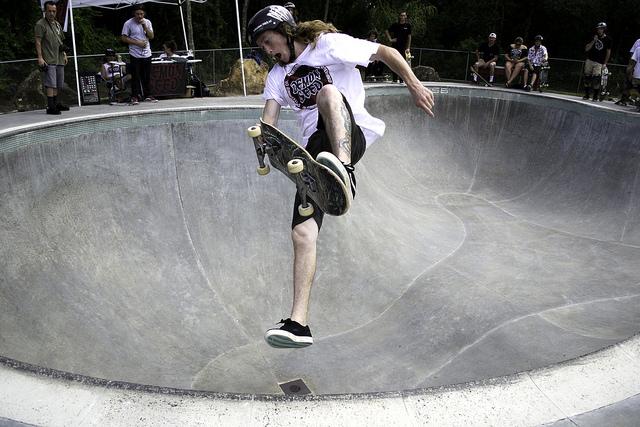What is he doing?
Be succinct. Skateboarding. How many people are skating?
Short answer required. 1. Is he doing a trick?
Give a very brief answer. Yes. 